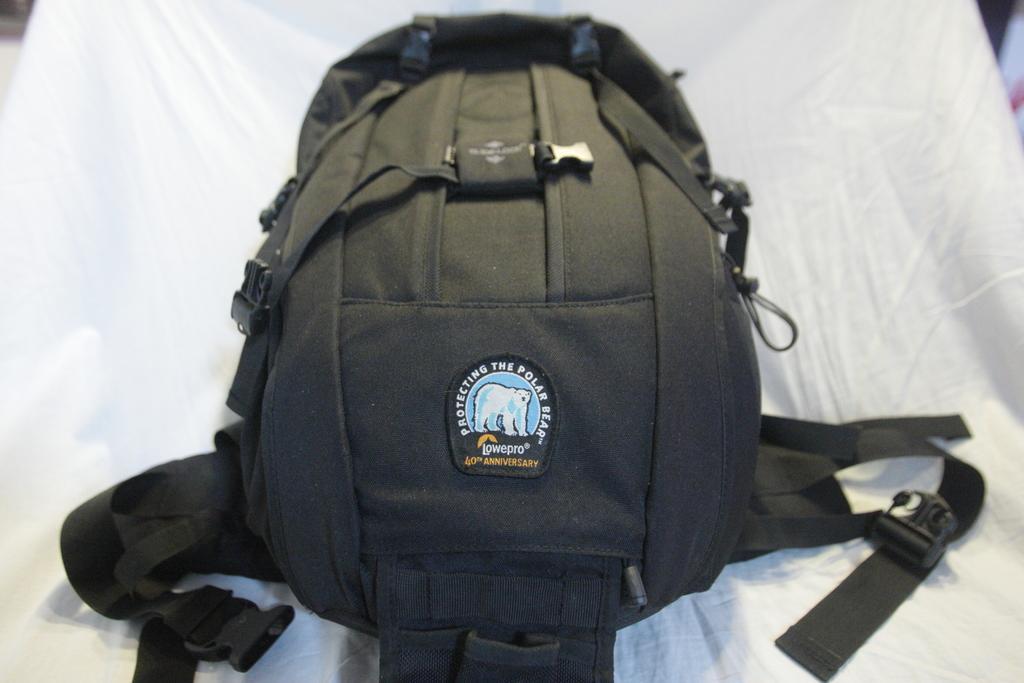In one or two sentences, can you explain what this image depicts? In this image I can see a bag 